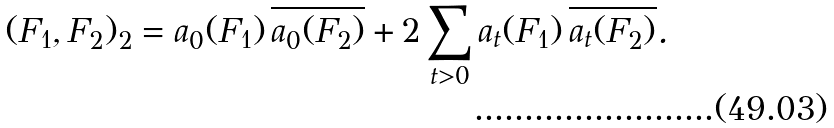Convert formula to latex. <formula><loc_0><loc_0><loc_500><loc_500>( F _ { 1 } , F _ { 2 } ) _ { 2 } = a _ { 0 } ( F _ { 1 } ) \, \overline { a _ { 0 } ( F _ { 2 } ) } + 2 \sum _ { t > 0 } a _ { t } ( F _ { 1 } ) \, \overline { a _ { t } ( F _ { 2 } ) } .</formula> 